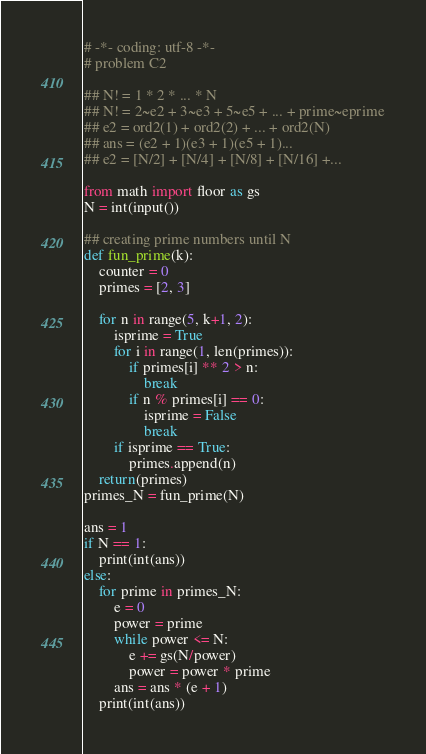Convert code to text. <code><loc_0><loc_0><loc_500><loc_500><_Python_># -*- coding: utf-8 -*-
# problem C2

## N! = 1 * 2 * ... * N
## N! = 2~e2 + 3~e3 + 5~e5 + ... + prime~eprime
## e2 = ord2(1) + ord2(2) + ... + ord2(N)
## ans = (e2 + 1)(e3 + 1)(e5 + 1)...
## e2 = [N/2] + [N/4] + [N/8] + [N/16] +...

from math import floor as gs
N = int(input())

## creating prime numbers until N
def fun_prime(k):
    counter = 0
    primes = [2, 3]

    for n in range(5, k+1, 2):
        isprime = True
        for i in range(1, len(primes)):
            if primes[i] ** 2 > n:
                break
            if n % primes[i] == 0:
                isprime = False
                break
        if isprime == True:
            primes.append(n)
    return(primes)
primes_N = fun_prime(N)

ans = 1
if N == 1:
    print(int(ans))
else:
    for prime in primes_N:
        e = 0
        power = prime
        while power <= N:
            e += gs(N/power)
            power = power * prime
        ans = ans * (e + 1)
    print(int(ans))    </code> 